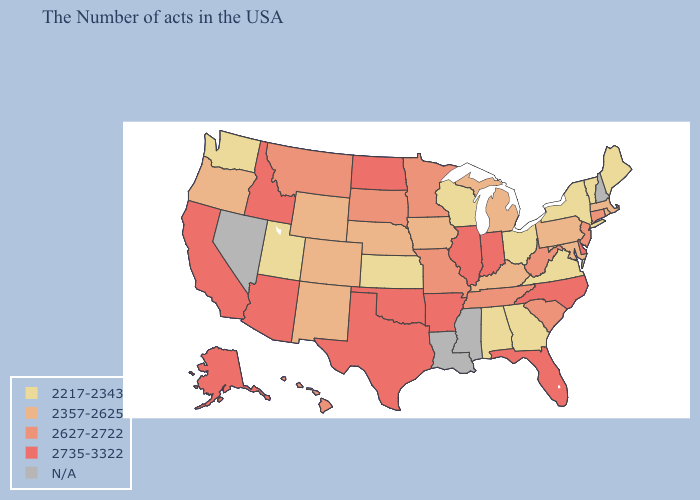Name the states that have a value in the range N/A?
Write a very short answer. New Hampshire, Mississippi, Louisiana, Nevada. Name the states that have a value in the range N/A?
Keep it brief. New Hampshire, Mississippi, Louisiana, Nevada. Name the states that have a value in the range 2735-3322?
Concise answer only. Delaware, North Carolina, Florida, Indiana, Illinois, Arkansas, Oklahoma, Texas, North Dakota, Arizona, Idaho, California, Alaska. Name the states that have a value in the range 2217-2343?
Short answer required. Maine, Vermont, New York, Virginia, Ohio, Georgia, Alabama, Wisconsin, Kansas, Utah, Washington. What is the value of Delaware?
Concise answer only. 2735-3322. Among the states that border Iowa , does Missouri have the highest value?
Keep it brief. No. Does the first symbol in the legend represent the smallest category?
Short answer required. Yes. Name the states that have a value in the range N/A?
Give a very brief answer. New Hampshire, Mississippi, Louisiana, Nevada. What is the highest value in the USA?
Write a very short answer. 2735-3322. What is the value of Connecticut?
Answer briefly. 2627-2722. What is the value of North Dakota?
Keep it brief. 2735-3322. Does Iowa have the highest value in the USA?
Short answer required. No. Does the map have missing data?
Quick response, please. Yes. What is the lowest value in the USA?
Concise answer only. 2217-2343. What is the highest value in the USA?
Write a very short answer. 2735-3322. 